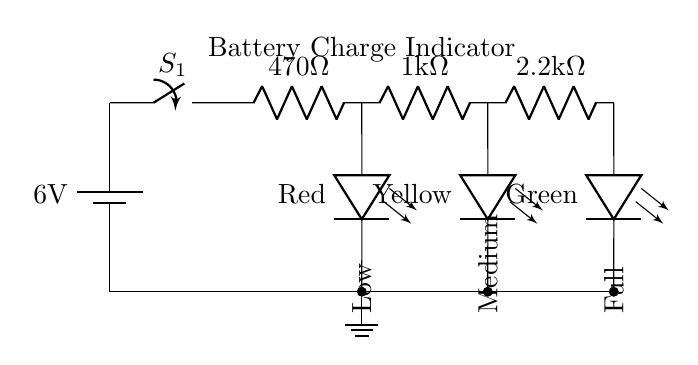What is the voltage of the battery? The circuit indicates a 6V battery, as labeled on the battery component in the diagram.
Answer: 6V What type of component is used to indicate low battery? The low battery indication is provided by a red LED, which is specifically labeled in the diagram.
Answer: Red LED How many resistors are present in the circuit? There are three resistors indicated in the circuit; they are labeled with their respective resistance values.
Answer: Three What is the resistance value of the first resistor? The first resistor has a resistance value of 470 ohms, which is displayed alongside its symbol in the diagram.
Answer: 470 ohms How are the LEDs connected in the circuit? The LEDs are connected in parallel, as they branch off from the same point in the circuit after the last resistor.
Answer: Parallel What does the yellow LED indicate? The yellow LED serves as a medium battery charge indicator, as per its labeling in the diagram, showing its function.
Answer: Medium What is the purpose of the switch in the circuit? The switch (S1) allows for the circuit to be opened or closed, thereby controlling the flow of current to the LEDs and indicating the battery status.
Answer: Control the circuit 